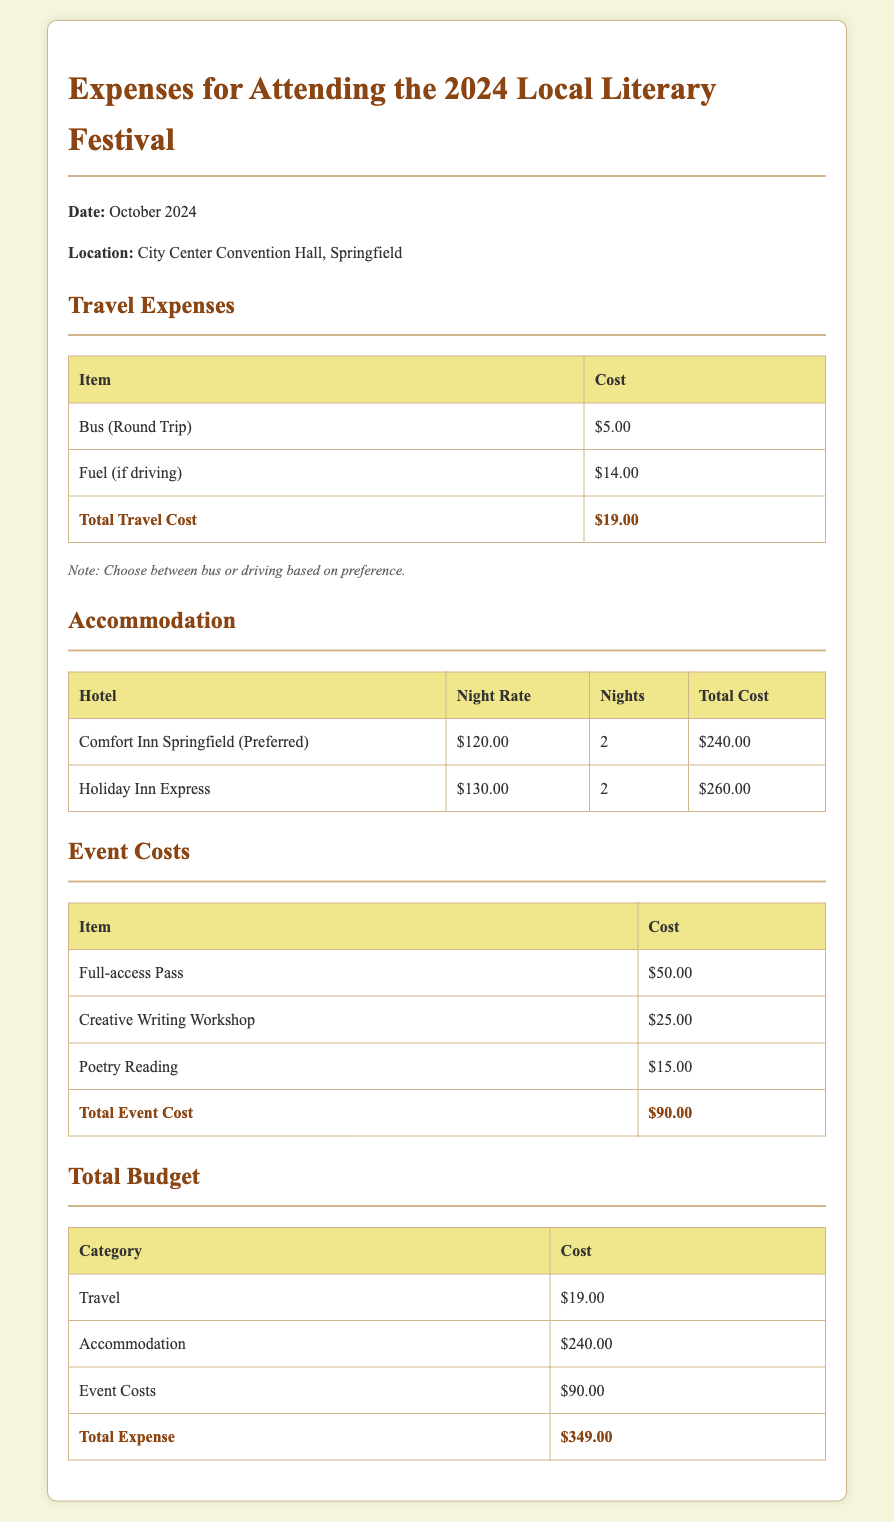What is the total travel cost? The total travel cost is given in the travel expenses section as $19.00.
Answer: $19.00 How much is the night rate at Comfort Inn Springfield? The night rate for Comfort Inn Springfield is listed as $120.00 in the accommodation section.
Answer: $120.00 What is the cost of the Full-access Pass? The cost of the Full-access Pass is stated as $50.00 in the event costs section.
Answer: $50.00 How many nights will the accommodation be booked for? The document specifies that accommodation will be booked for 2 nights.
Answer: 2 What is the total expense for attending the festival? The total expense is calculated at the bottom of the budget as $349.00.
Answer: $349.00 Which hotel is the preferred option for accommodation? The preferred option for accommodation is Comfort Inn Springfield according to the accommodation section.
Answer: Comfort Inn Springfield What is the combined total of the accommodation costs? The combined total of the accommodation costs for both hotels is $240.00 for Comfort Inn Springfield and $260.00 for Holiday Inn Express, but the budget lists the preferred option.
Answer: $240.00 What kind of workshop is included in the event costs? The workshop included in the event costs is a Creative Writing Workshop.
Answer: Creative Writing Workshop 